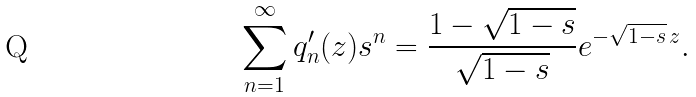<formula> <loc_0><loc_0><loc_500><loc_500>\sum _ { n = 1 } ^ { \infty } q _ { n } ^ { \prime } ( z ) s ^ { n } = \frac { 1 - \sqrt { 1 - s } } { \sqrt { 1 - s } } e ^ { - \sqrt { 1 - s } \, z } .</formula> 